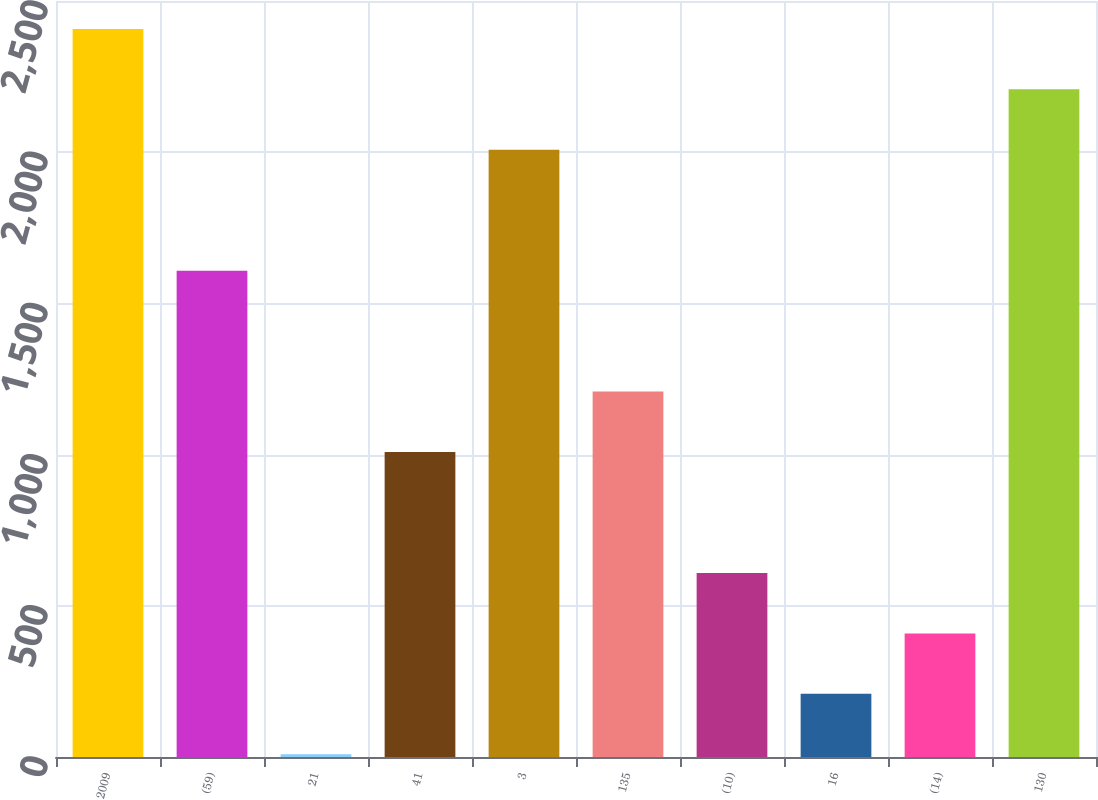Convert chart. <chart><loc_0><loc_0><loc_500><loc_500><bar_chart><fcel>2009<fcel>(59)<fcel>21<fcel>41<fcel>3<fcel>135<fcel>(10)<fcel>16<fcel>(14)<fcel>130<nl><fcel>2407.8<fcel>1608.2<fcel>9<fcel>1008.5<fcel>2008<fcel>1208.4<fcel>608.7<fcel>208.9<fcel>408.8<fcel>2207.9<nl></chart> 